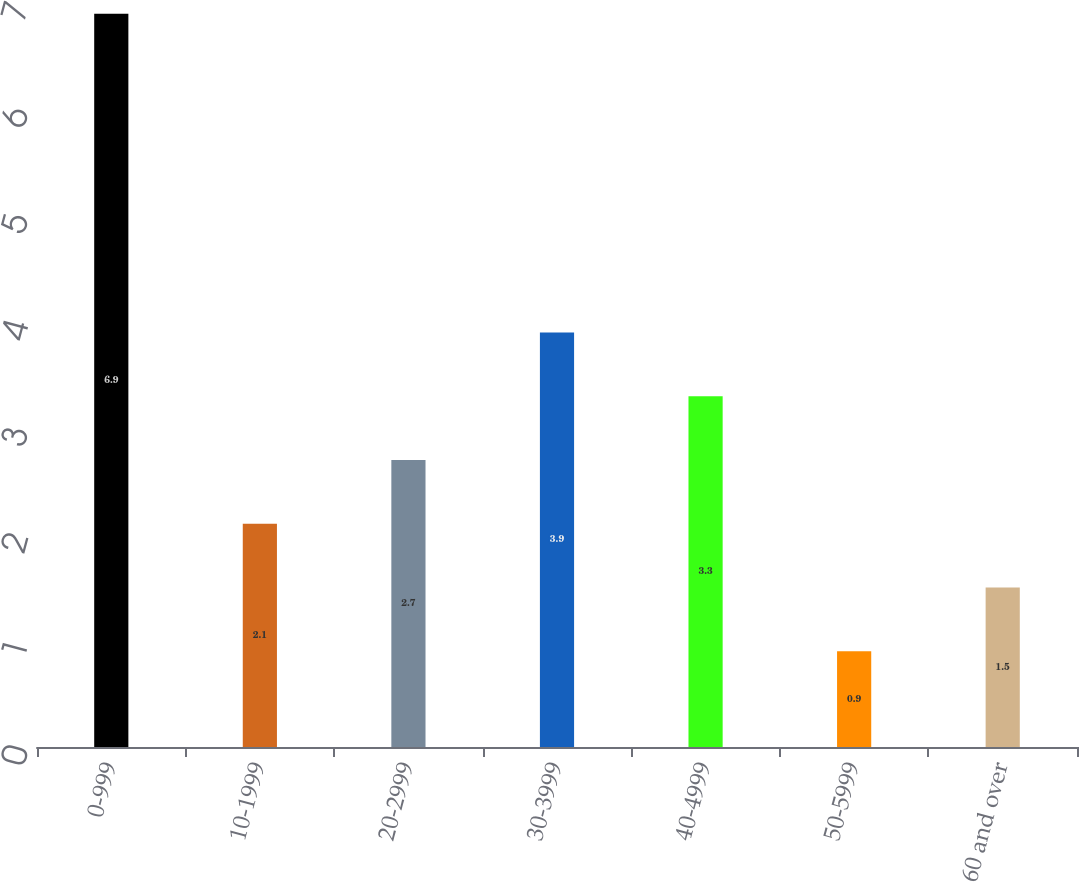Convert chart. <chart><loc_0><loc_0><loc_500><loc_500><bar_chart><fcel>0-999<fcel>10-1999<fcel>20-2999<fcel>30-3999<fcel>40-4999<fcel>50-5999<fcel>60 and over<nl><fcel>6.9<fcel>2.1<fcel>2.7<fcel>3.9<fcel>3.3<fcel>0.9<fcel>1.5<nl></chart> 